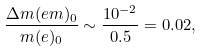<formula> <loc_0><loc_0><loc_500><loc_500>\frac { \Delta m ( e m ) _ { 0 } } { m ( e ) _ { 0 } } \sim \frac { 1 0 ^ { - 2 } } { 0 . 5 } = 0 . 0 2 ,</formula> 